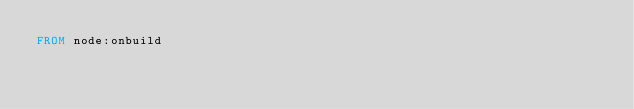<code> <loc_0><loc_0><loc_500><loc_500><_Dockerfile_>FROM node:onbuild
</code> 